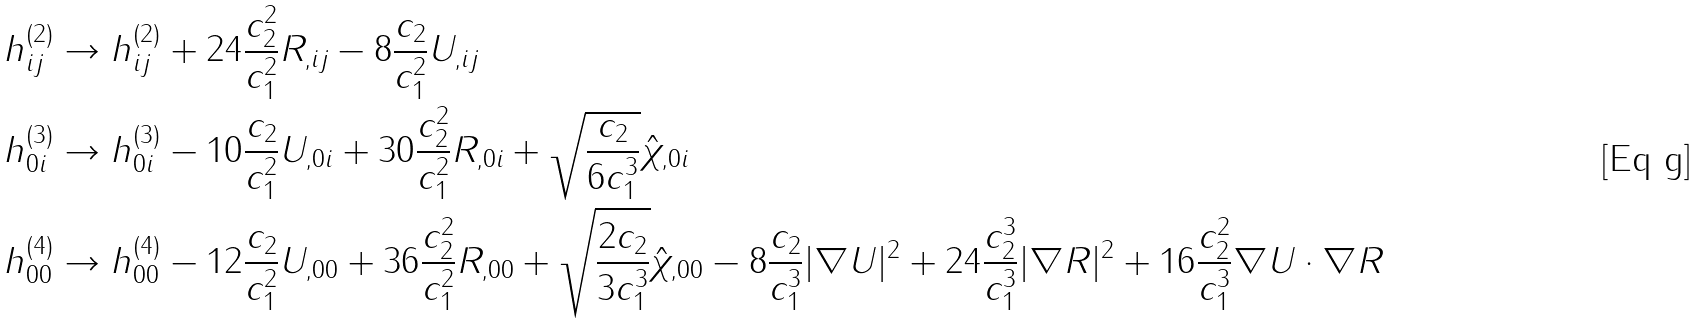Convert formula to latex. <formula><loc_0><loc_0><loc_500><loc_500>h _ { i j } ^ { ( 2 ) } & \rightarrow h _ { i j } ^ { ( 2 ) } + 2 4 \frac { c _ { 2 } ^ { 2 } } { c _ { 1 } ^ { 2 } } R _ { , i j } - 8 \frac { c _ { 2 } } { c _ { 1 } ^ { 2 } } U _ { , i j } \\ h _ { 0 i } ^ { ( 3 ) } & \rightarrow h _ { 0 i } ^ { ( 3 ) } - 1 0 \frac { c _ { 2 } } { c _ { 1 } ^ { 2 } } U _ { , 0 i } + 3 0 \frac { c _ { 2 } ^ { 2 } } { c _ { 1 } ^ { 2 } } R _ { , 0 i } + \sqrt { \frac { c _ { 2 } } { 6 c _ { 1 } ^ { 3 } } } \hat { \chi } _ { , 0 i } \\ h _ { 0 0 } ^ { ( 4 ) } & \rightarrow h _ { 0 0 } ^ { ( 4 ) } - 1 2 \frac { c _ { 2 } } { c _ { 1 } ^ { 2 } } U _ { , 0 0 } + 3 6 \frac { c _ { 2 } ^ { 2 } } { c _ { 1 } ^ { 2 } } R _ { , 0 0 } + \sqrt { \frac { 2 c _ { 2 } } { 3 c _ { 1 } ^ { 3 } } } \hat { \chi } _ { , 0 0 } - 8 \frac { c _ { 2 } } { c _ { 1 } ^ { 3 } } | \nabla U | ^ { 2 } + 2 4 \frac { c _ { 2 } ^ { 3 } } { c _ { 1 } ^ { 3 } } | \nabla R | ^ { 2 } + 1 6 \frac { c _ { 2 } ^ { 2 } } { c _ { 1 } ^ { 3 } } \nabla U \cdot \nabla R</formula> 